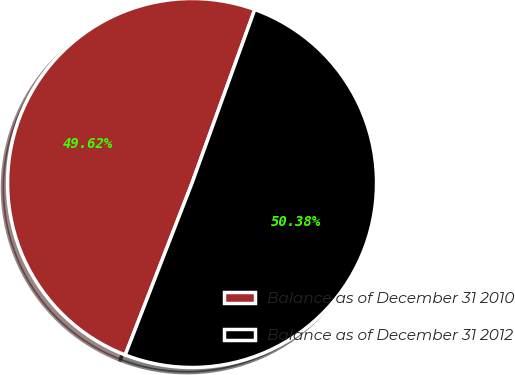<chart> <loc_0><loc_0><loc_500><loc_500><pie_chart><fcel>Balance as of December 31 2010<fcel>Balance as of December 31 2012<nl><fcel>49.62%<fcel>50.38%<nl></chart> 